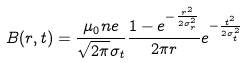<formula> <loc_0><loc_0><loc_500><loc_500>B ( r , t ) = \frac { \mu _ { 0 } n e } { \sqrt { 2 \pi } \sigma _ { t } } \frac { 1 - e ^ { - \frac { r ^ { 2 } } { 2 \sigma _ { r } ^ { 2 } } } } { 2 \pi r } e ^ { - \frac { t ^ { 2 } } { 2 \sigma _ { t } ^ { 2 } } }</formula> 